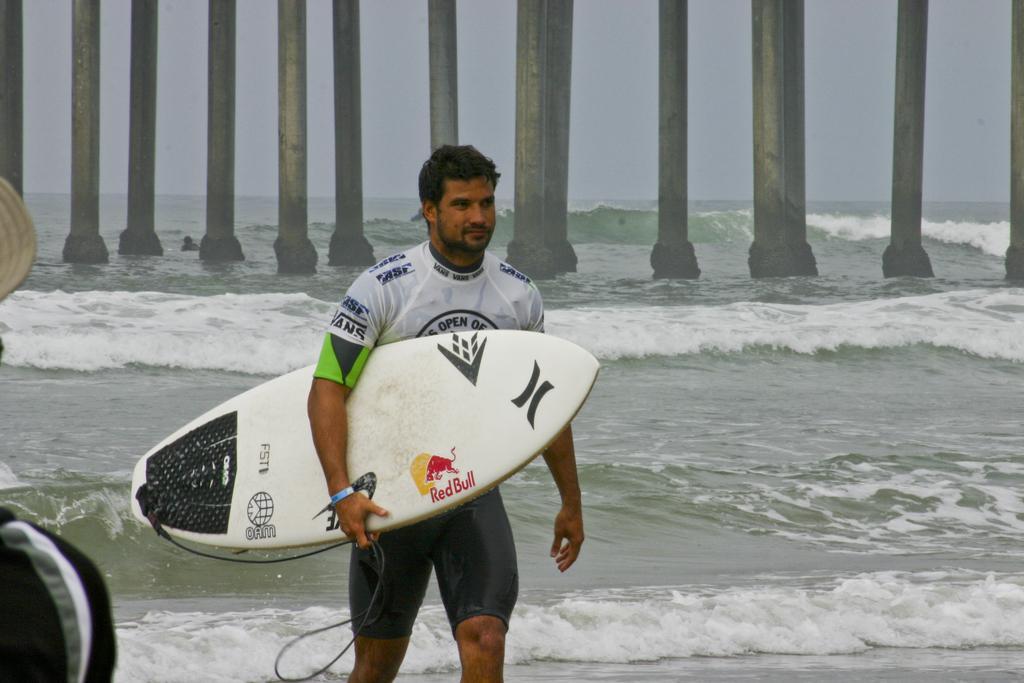Please provide a concise description of this image. This picture is captured outside. A person is walking by holding a surfboard wearing white shirt. At the background there is water and pillars and sky. At left side there is a person wearing a cap. 